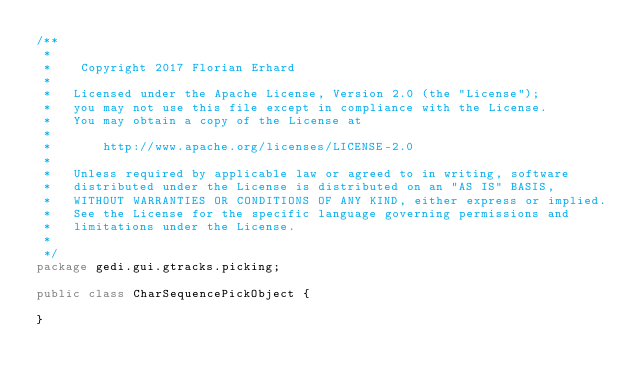<code> <loc_0><loc_0><loc_500><loc_500><_Java_>/**
 * 
 *    Copyright 2017 Florian Erhard
 *
 *   Licensed under the Apache License, Version 2.0 (the "License");
 *   you may not use this file except in compliance with the License.
 *   You may obtain a copy of the License at
 *
 *       http://www.apache.org/licenses/LICENSE-2.0
 *
 *   Unless required by applicable law or agreed to in writing, software
 *   distributed under the License is distributed on an "AS IS" BASIS,
 *   WITHOUT WARRANTIES OR CONDITIONS OF ANY KIND, either express or implied.
 *   See the License for the specific language governing permissions and
 *   limitations under the License.
 * 
 */
package gedi.gui.gtracks.picking;

public class CharSequencePickObject {

}
</code> 